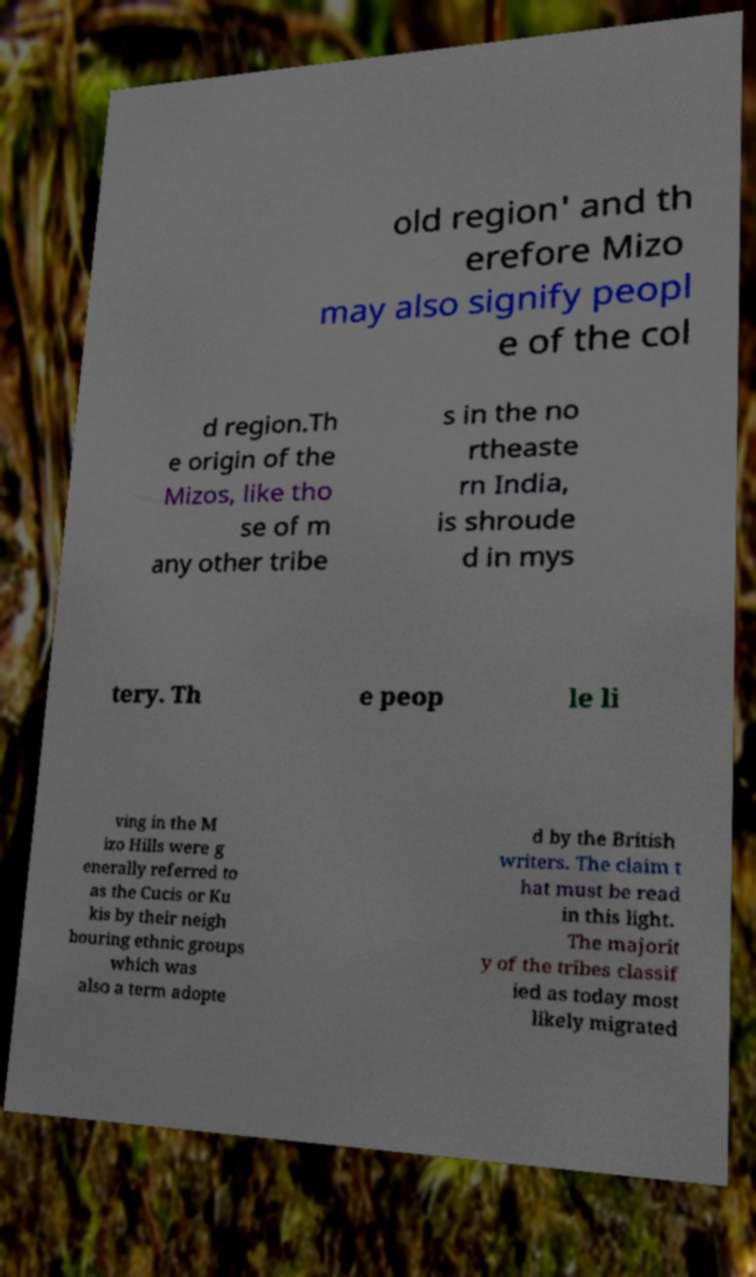Can you accurately transcribe the text from the provided image for me? old region' and th erefore Mizo may also signify peopl e of the col d region.Th e origin of the Mizos, like tho se of m any other tribe s in the no rtheaste rn India, is shroude d in mys tery. Th e peop le li ving in the M izo Hills were g enerally referred to as the Cucis or Ku kis by their neigh bouring ethnic groups which was also a term adopte d by the British writers. The claim t hat must be read in this light. The majorit y of the tribes classif ied as today most likely migrated 